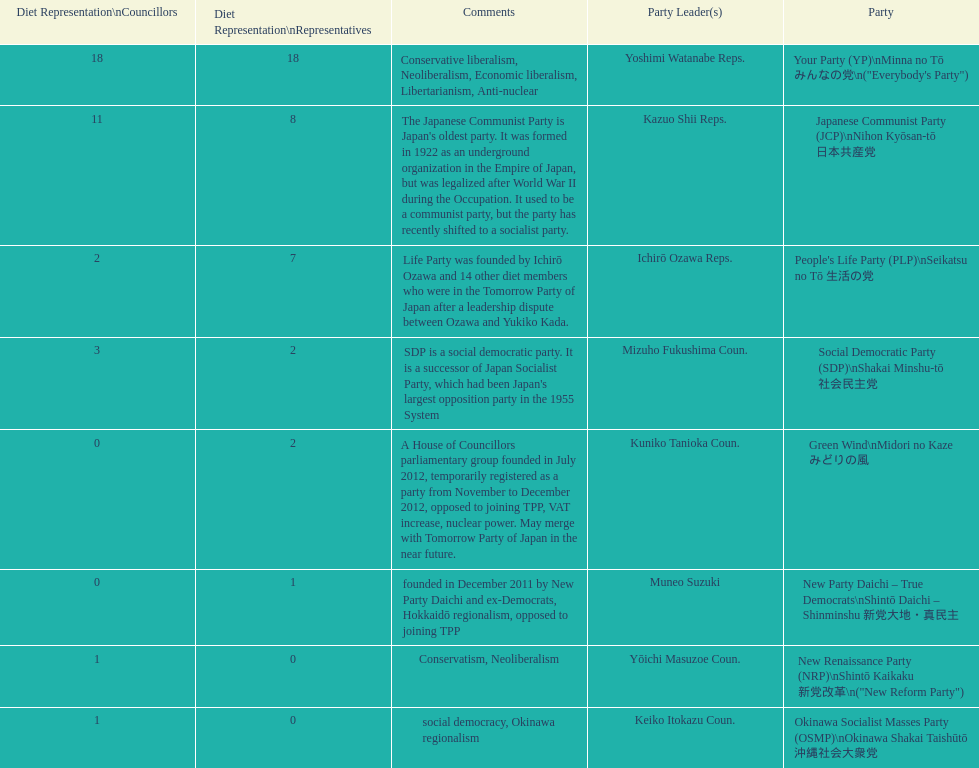How many representatives come from the green wind party? 2. 